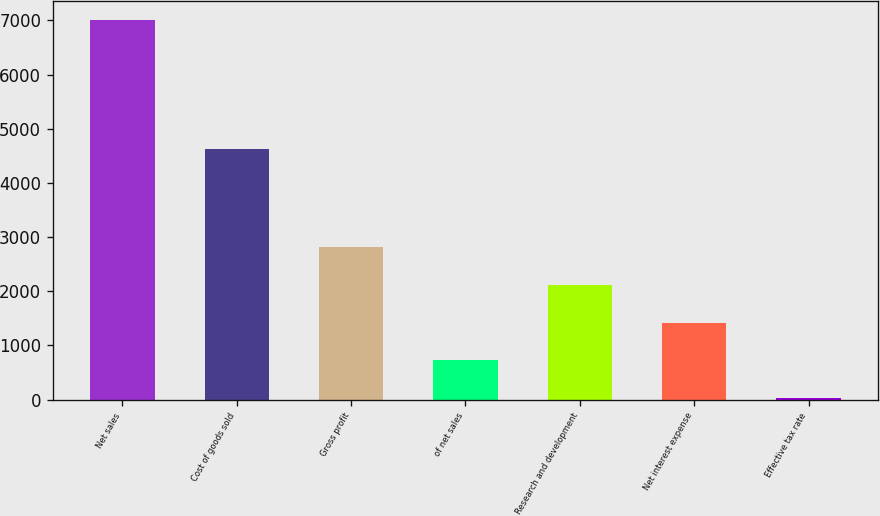<chart> <loc_0><loc_0><loc_500><loc_500><bar_chart><fcel>Net sales<fcel>Cost of goods sold<fcel>Gross profit<fcel>of net sales<fcel>Research and development<fcel>Net interest expense<fcel>Effective tax rate<nl><fcel>6999.7<fcel>4629.6<fcel>2815.18<fcel>722.92<fcel>2117.76<fcel>1420.34<fcel>25.5<nl></chart> 